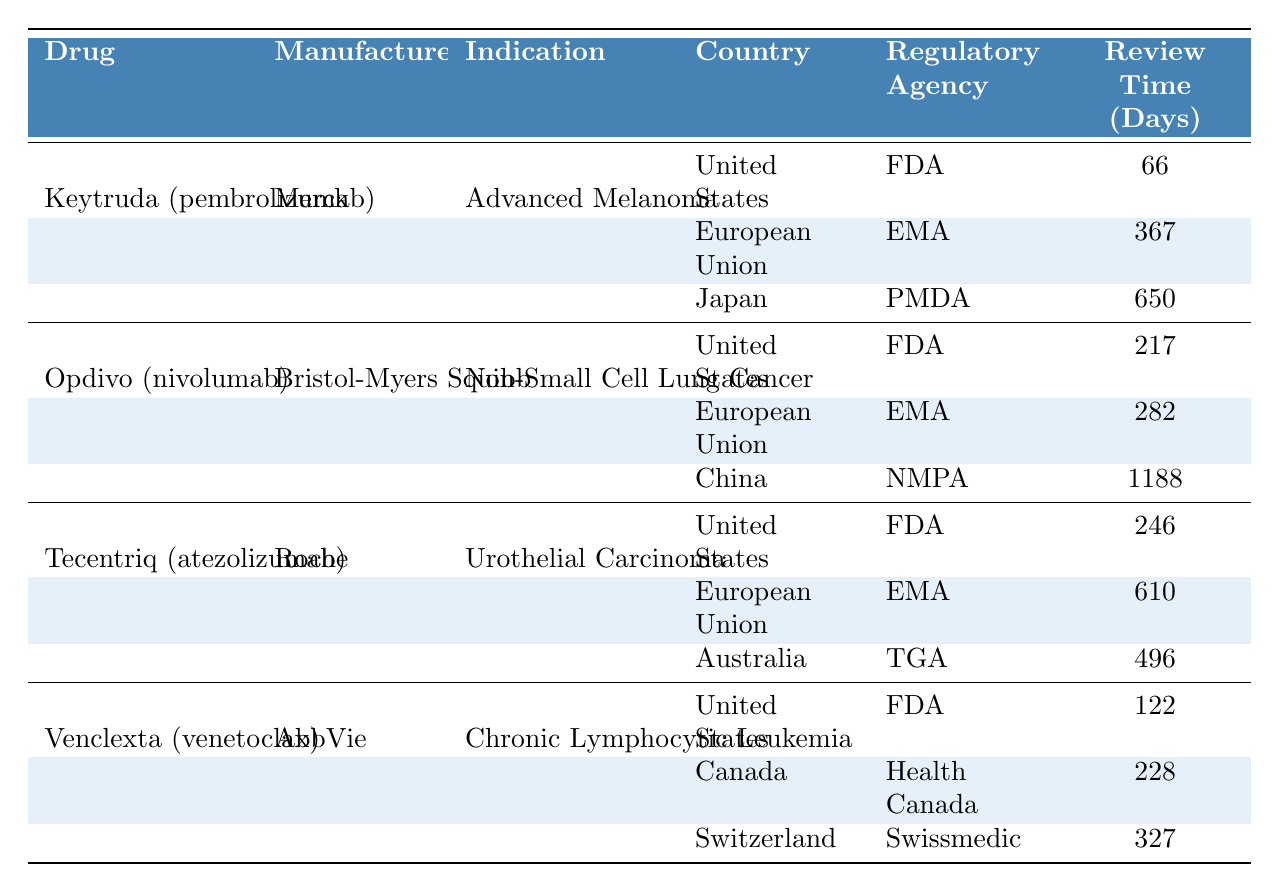What is the review time for Keytruda's approval in the United States? The review time for Keytruda in the United States is explicitly listed in the table under the FDA agency. It shows 66 days as the review time.
Answer: 66 days Which drug has the longest review time in Japan? By checking the entries for Japan in the "Review Time (Days)" column, Keytruda has a review time of 650 days, which is the highest compared to other listed drugs in Japan.
Answer: Keytruda (pembrolizumab) What is the average review time for Opdivo across all countries? To find the average review time, sum the review times for Opdivo: 217 days (US) + 282 days (EU) + 1188 days (China) = 1687 days. Then, divide by 3 (countries): 1687 / 3 ≈ 562.33 days.
Answer: Approximately 562 days Is the approval of Venclexta faster in the United States than in Canada? Comparing the review times, Venclexta took 122 days in the United States and 228 days in Canada. Since 122 is less than 228, the approval in the United States is faster.
Answer: Yes How many days longer did it take to approve Tecentriq in the European Union compared to the United States? First, find the review duration for each: Tecentriq took 246 days in the US and 610 days in the EU. Subtract the US duration from the EU duration: 610 - 246 = 364 days.
Answer: 364 days Which drug has the highest total review time across all countries listed? By totaling the review times for each drug: Keytruda (66 + 367 + 650 = 1083), Opdivo (217 + 282 + 1188 = 1687), Tecentriq (246 + 610 + 496 = 1352), and Venclexta (122 + 228 + 327 = 677). Opdivo has the highest at 1687 days.
Answer: Opdivo (nivolumab) In which country did Venclexta receive its approval the quickest? The review times are as follows for Venclexta: 122 days in the US, 228 days in Canada, and 327 days in Switzerland. The quickest approval was in the United States with 122 days.
Answer: United States What is the total review time for all drugs across all listed countries? Sum the review times for all entries: (66 + 367 + 650) + (217 + 282 + 1188) + (246 + 610 + 496) + (122 + 228 + 327) = 2021 + 1687 + 1352 + 677 = 5737 days in total.
Answer: 5737 days Did the submission date for Opdivo in the United States precede its approval date? The submission date for Opdivo in the US is 2014-07-30, while the approval date is 2015-03-04. Since the submission date is before the approval date, it indicates the correct sequence of events.
Answer: Yes 